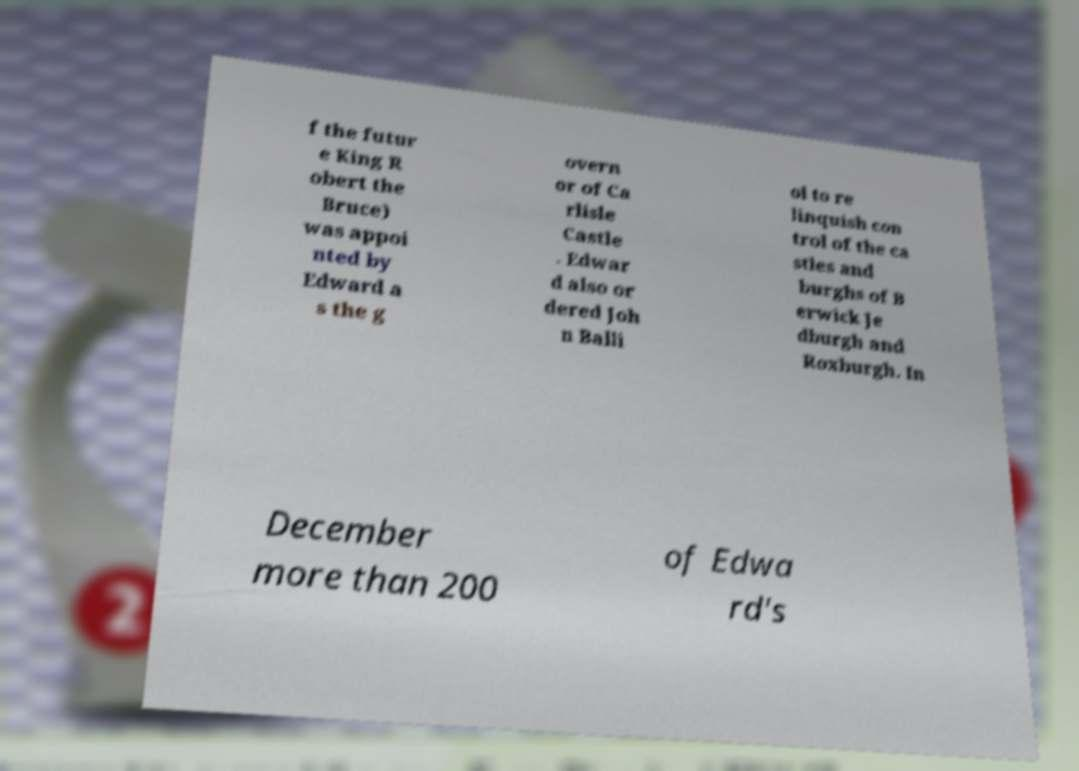There's text embedded in this image that I need extracted. Can you transcribe it verbatim? f the futur e King R obert the Bruce) was appoi nted by Edward a s the g overn or of Ca rlisle Castle . Edwar d also or dered Joh n Balli ol to re linquish con trol of the ca stles and burghs of B erwick Je dburgh and Roxburgh. In December more than 200 of Edwa rd's 